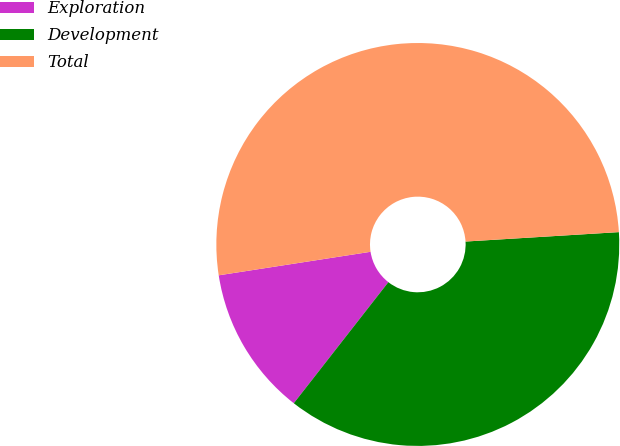<chart> <loc_0><loc_0><loc_500><loc_500><pie_chart><fcel>Exploration<fcel>Development<fcel>Total<nl><fcel>12.0%<fcel>36.53%<fcel>51.47%<nl></chart> 